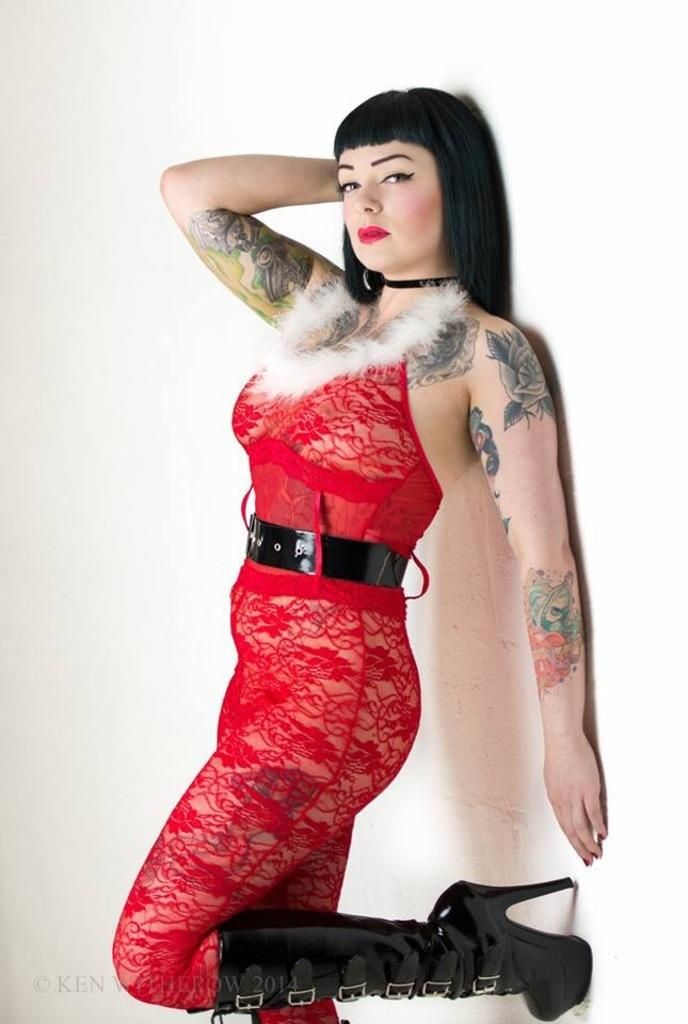What is the main subject of the image? There is a lady standing in the center of the image. What is the lady wearing in the image? The lady is wearing costumes and heels. What can be seen at the bottom of the image? There is some text at the bottom of the image. What is visible in the background of the image? There is a wall in the background of the image. Can you see any cactus in the image? There is no cactus present in the image. What is the lady rubbing on her hands in the image? The image does not show the lady rubbing anything on her hands. 